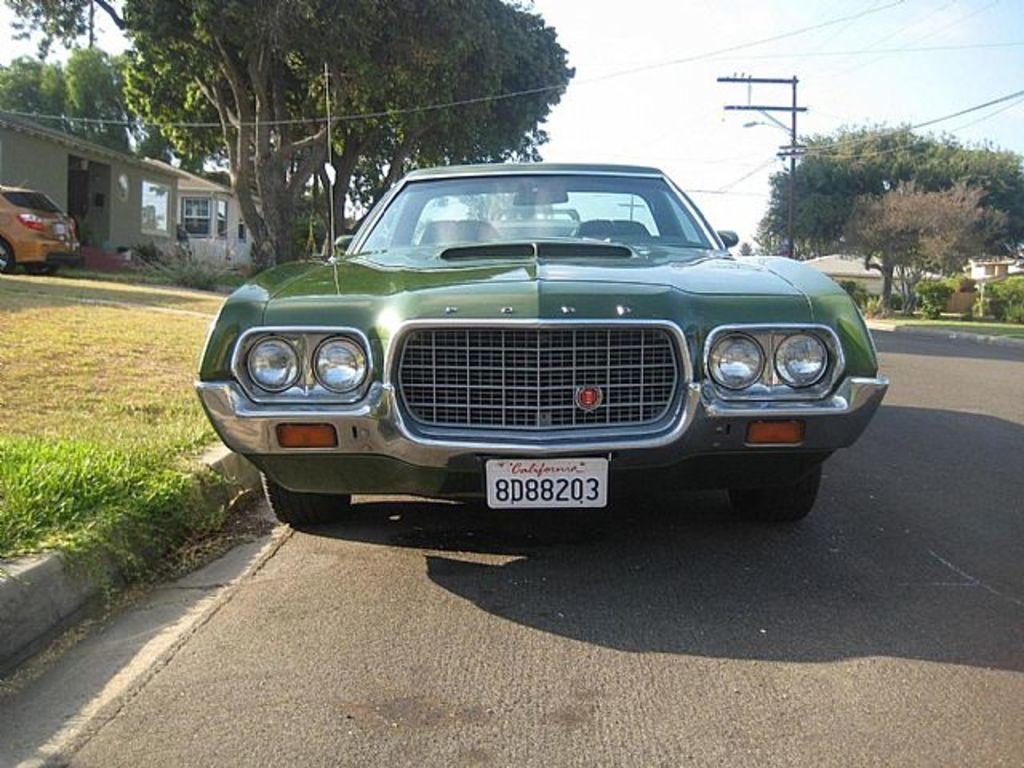What type of vegetation is present in the image? There is grass in the image. What type of man-made structures can be seen in the image? There are houses in the image. What type of vehicles are visible in the image? There are cars in the image. What other types of vegetation can be seen in the image? There are trees and plants in the image. What utility pole is present in the image? There is a current pole in the image. What is visible at the top of the image? The sky is visible at the top of the image. What type of wrench is being used to fix the trees in the image? There is no wrench present in the image, and the trees do not require fixing. What type of teeth can be seen on the cars in the image? Cars do not have teeth, and there is no reference to teeth in the image. 